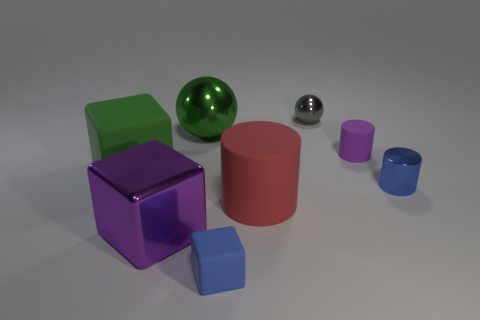Subtract 1 cylinders. How many cylinders are left? 2 Add 1 red cylinders. How many objects exist? 9 Subtract all cubes. How many objects are left? 5 Add 1 green spheres. How many green spheres exist? 2 Subtract 0 yellow balls. How many objects are left? 8 Subtract all large green metal objects. Subtract all purple cylinders. How many objects are left? 6 Add 6 blue objects. How many blue objects are left? 8 